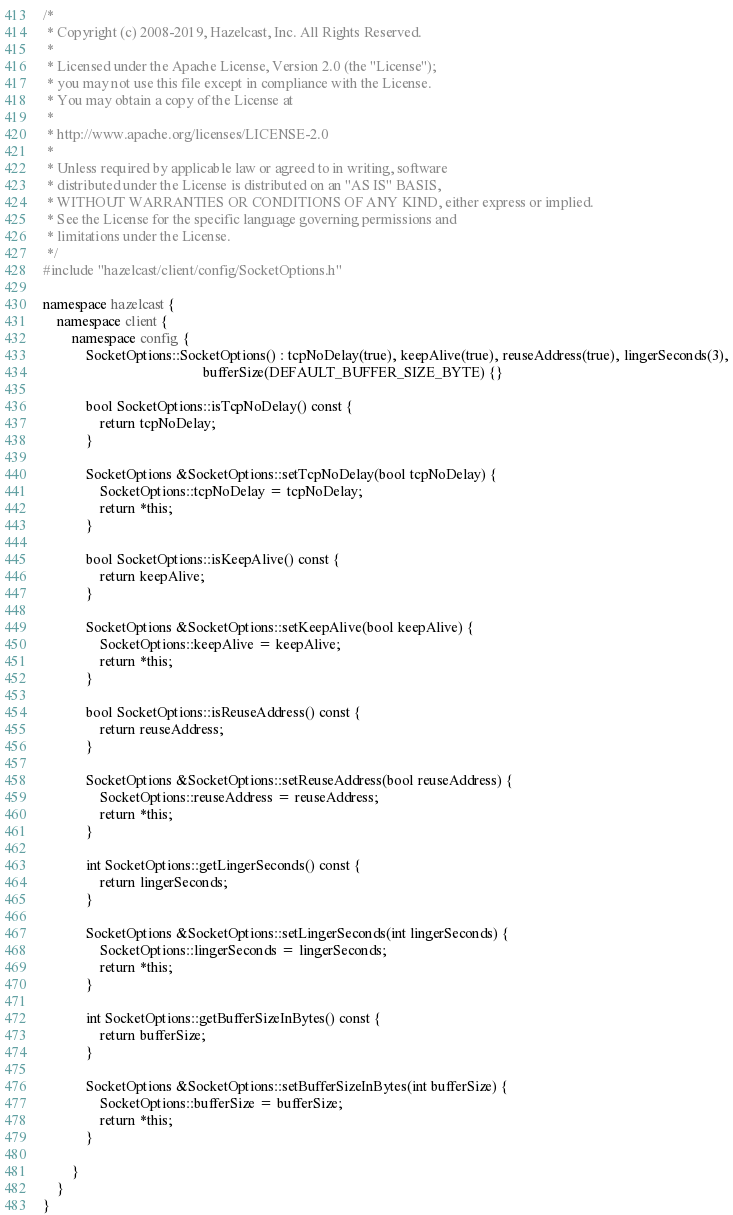Convert code to text. <code><loc_0><loc_0><loc_500><loc_500><_C++_>/*
 * Copyright (c) 2008-2019, Hazelcast, Inc. All Rights Reserved.
 *
 * Licensed under the Apache License, Version 2.0 (the "License");
 * you may not use this file except in compliance with the License.
 * You may obtain a copy of the License at
 *
 * http://www.apache.org/licenses/LICENSE-2.0
 *
 * Unless required by applicable law or agreed to in writing, software
 * distributed under the License is distributed on an "AS IS" BASIS,
 * WITHOUT WARRANTIES OR CONDITIONS OF ANY KIND, either express or implied.
 * See the License for the specific language governing permissions and
 * limitations under the License.
 */
#include "hazelcast/client/config/SocketOptions.h"

namespace hazelcast {
    namespace client {
        namespace config {
            SocketOptions::SocketOptions() : tcpNoDelay(true), keepAlive(true), reuseAddress(true), lingerSeconds(3),
                                             bufferSize(DEFAULT_BUFFER_SIZE_BYTE) {}

            bool SocketOptions::isTcpNoDelay() const {
                return tcpNoDelay;
            }

            SocketOptions &SocketOptions::setTcpNoDelay(bool tcpNoDelay) {
                SocketOptions::tcpNoDelay = tcpNoDelay;
                return *this;
            }

            bool SocketOptions::isKeepAlive() const {
                return keepAlive;
            }

            SocketOptions &SocketOptions::setKeepAlive(bool keepAlive) {
                SocketOptions::keepAlive = keepAlive;
                return *this;
            }

            bool SocketOptions::isReuseAddress() const {
                return reuseAddress;
            }

            SocketOptions &SocketOptions::setReuseAddress(bool reuseAddress) {
                SocketOptions::reuseAddress = reuseAddress;
                return *this;
            }

            int SocketOptions::getLingerSeconds() const {
                return lingerSeconds;
            }

            SocketOptions &SocketOptions::setLingerSeconds(int lingerSeconds) {
                SocketOptions::lingerSeconds = lingerSeconds;
                return *this;
            }

            int SocketOptions::getBufferSizeInBytes() const {
                return bufferSize;
            }

            SocketOptions &SocketOptions::setBufferSizeInBytes(int bufferSize) {
                SocketOptions::bufferSize = bufferSize;
                return *this;
            }

        }
    }
}
</code> 